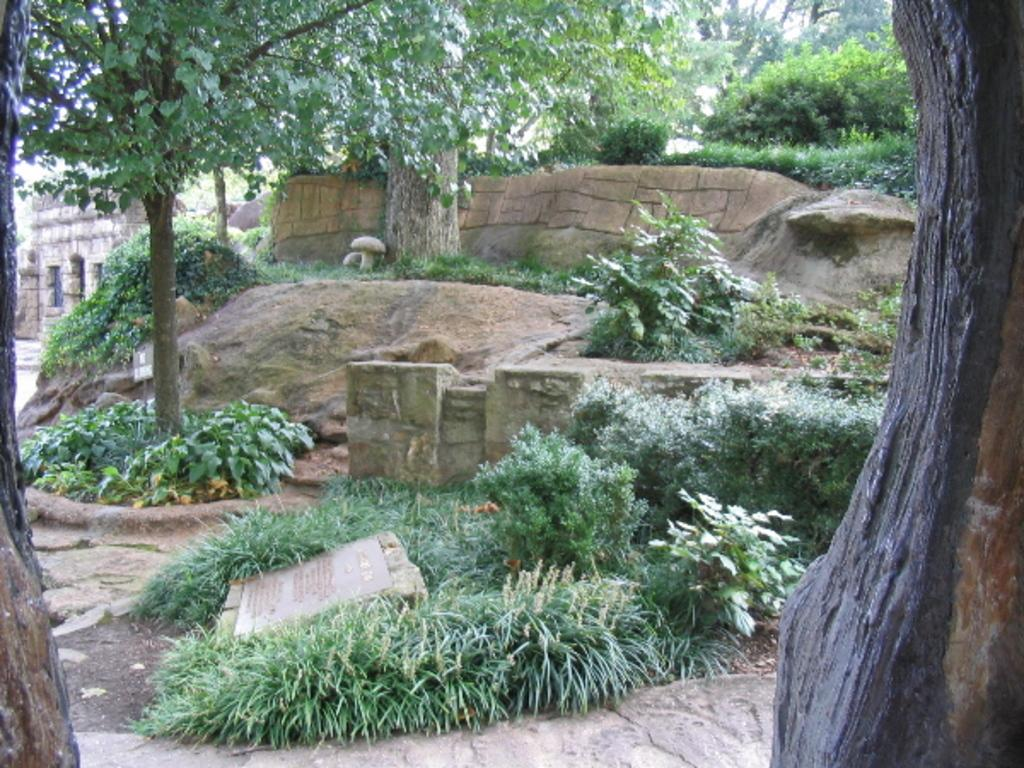What type of vegetation can be seen in the image? There are plants and trees in the image. What type of structure is visible in the image? There is a building in the image. What is located on the ground in the image? There is a stone with text on the ground in the image. What type of hat is being worn by the group of people in the image? There are no people or hats present in the image. What is the tax rate for the building in the image? The image does not provide information about the tax rate for the building. 